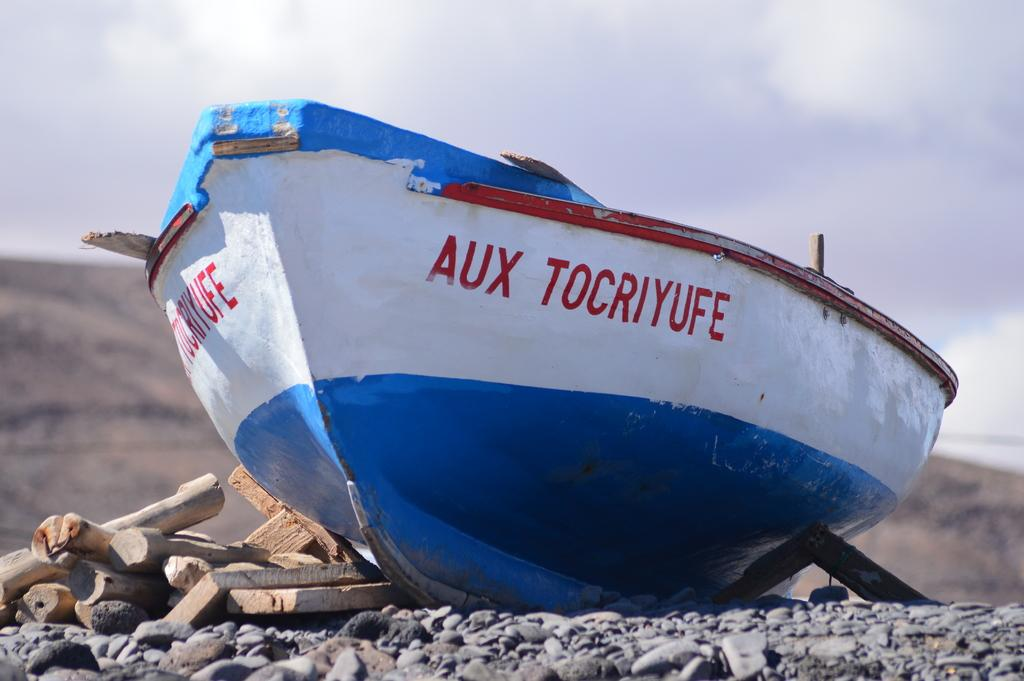What type of materials can be seen in the image? There are wood pieces and stones in the image. What is the main subject in the middle of the image? There is a boat in the middle of the image. What is visible at the top of the image? The sky is visible at the top of the image. What type of cake is being served on the boat in the image? There is no cake present in the image; it features wood pieces, stones, and a boat. How does the earthquake affect the boat in the image? There is no earthquake present in the image, so its impact on the boat cannot be determined. 